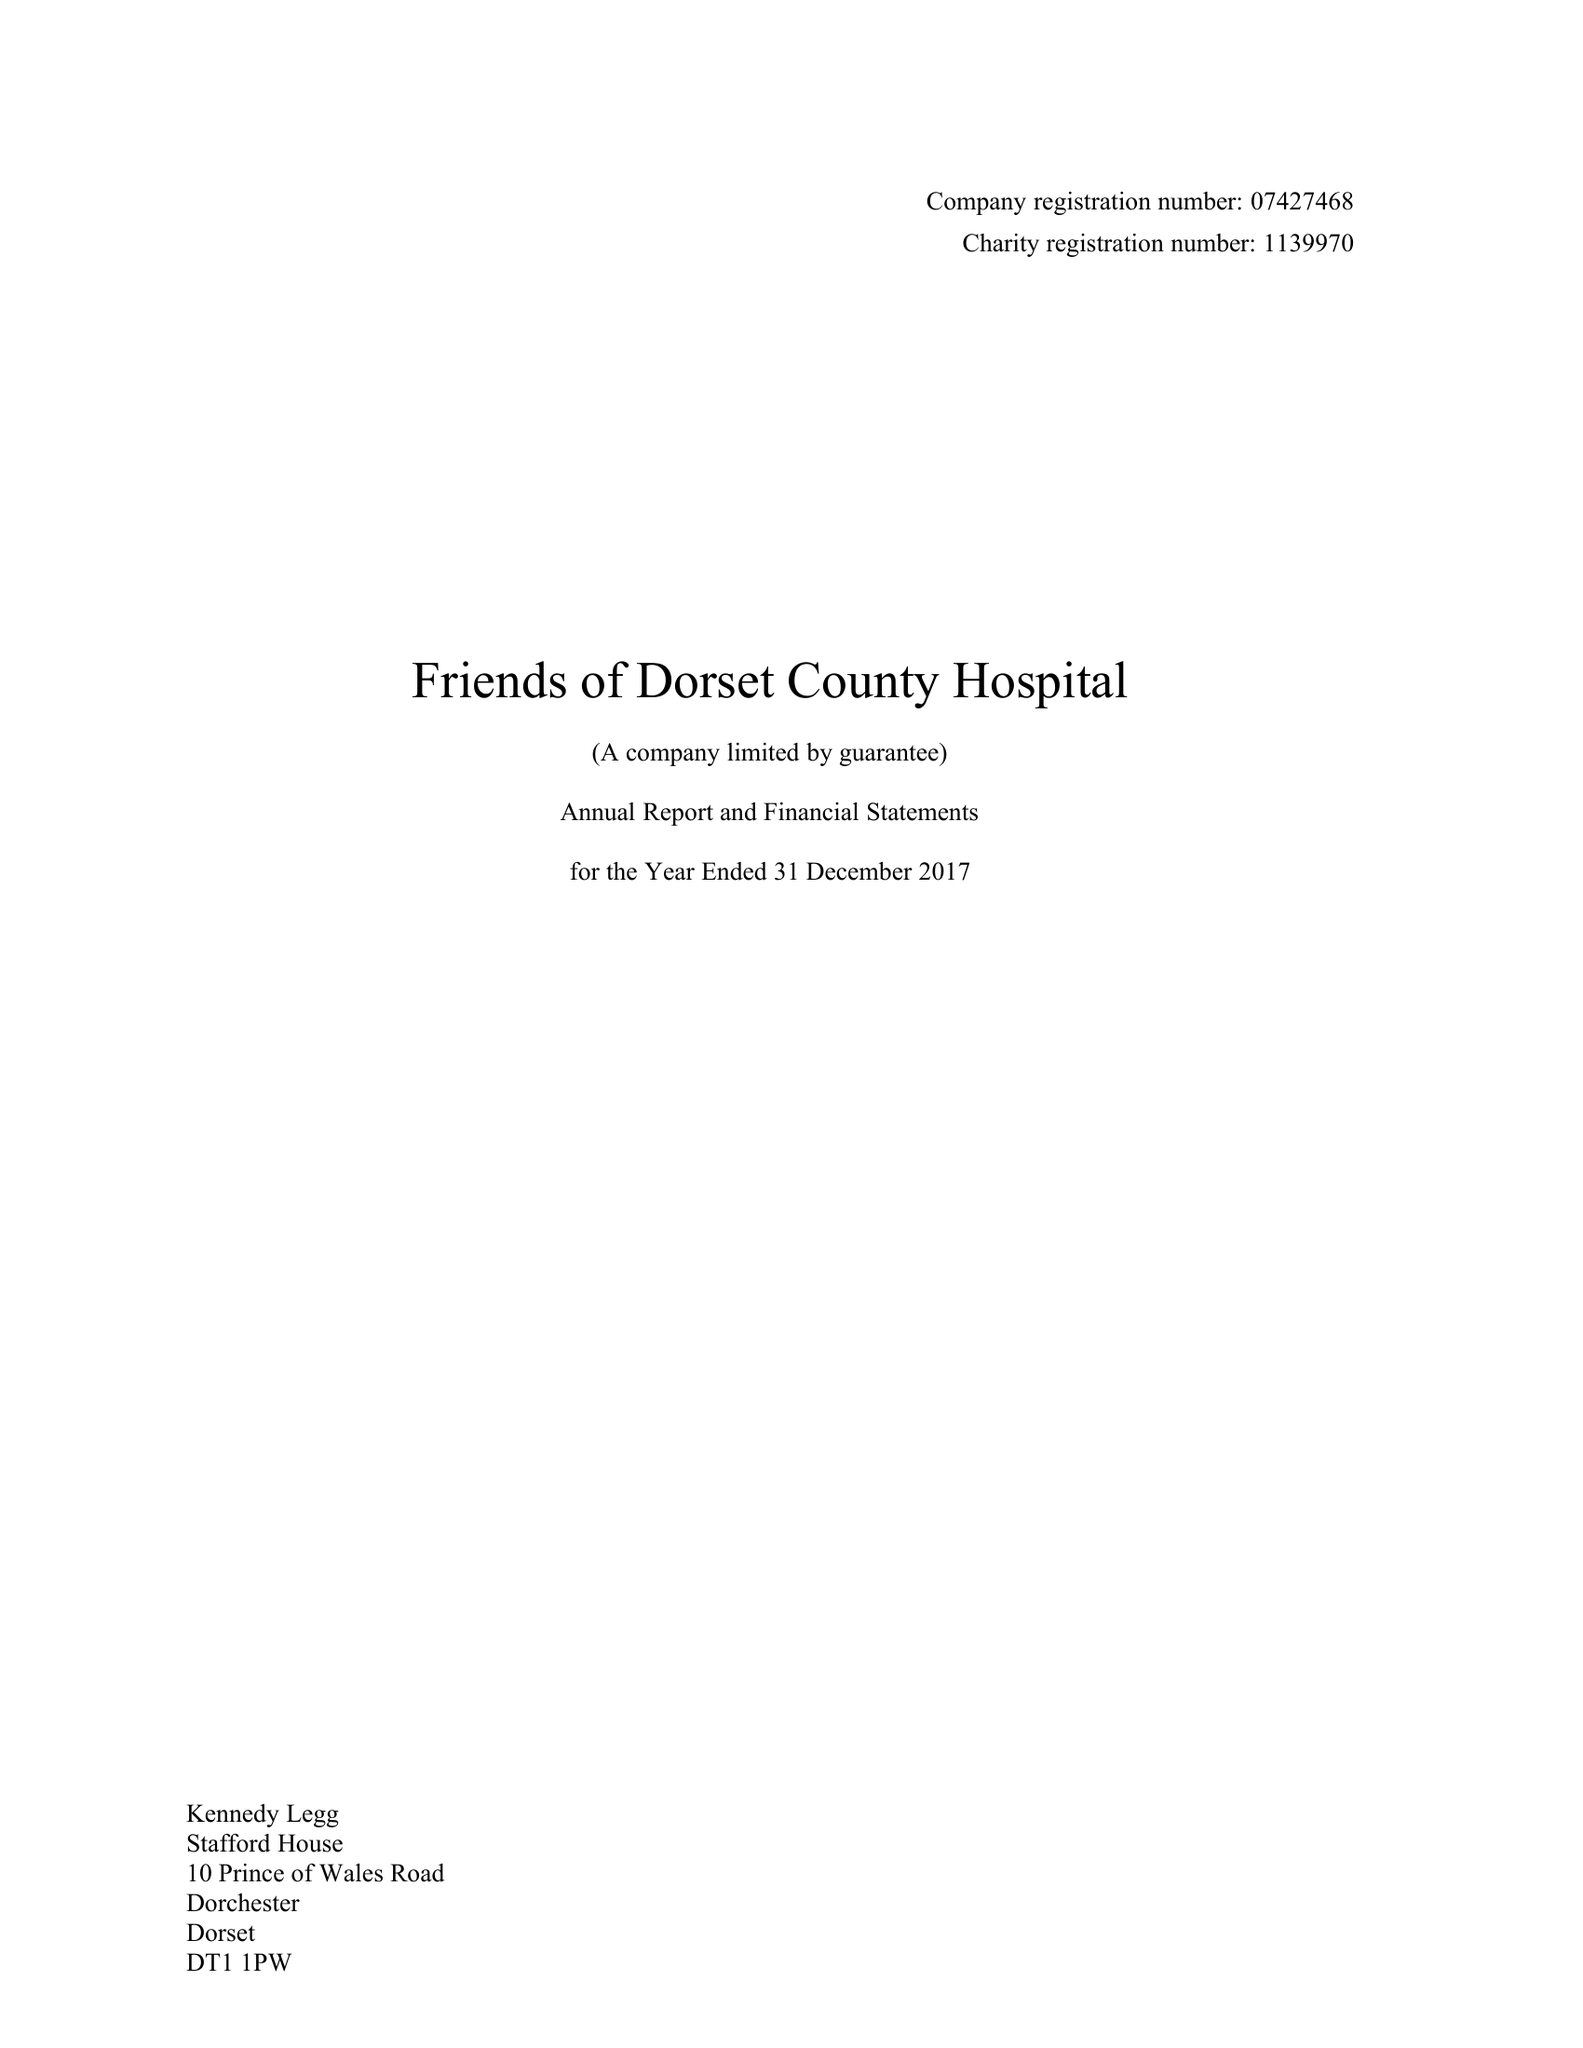What is the value for the report_date?
Answer the question using a single word or phrase. 2017-12-31 